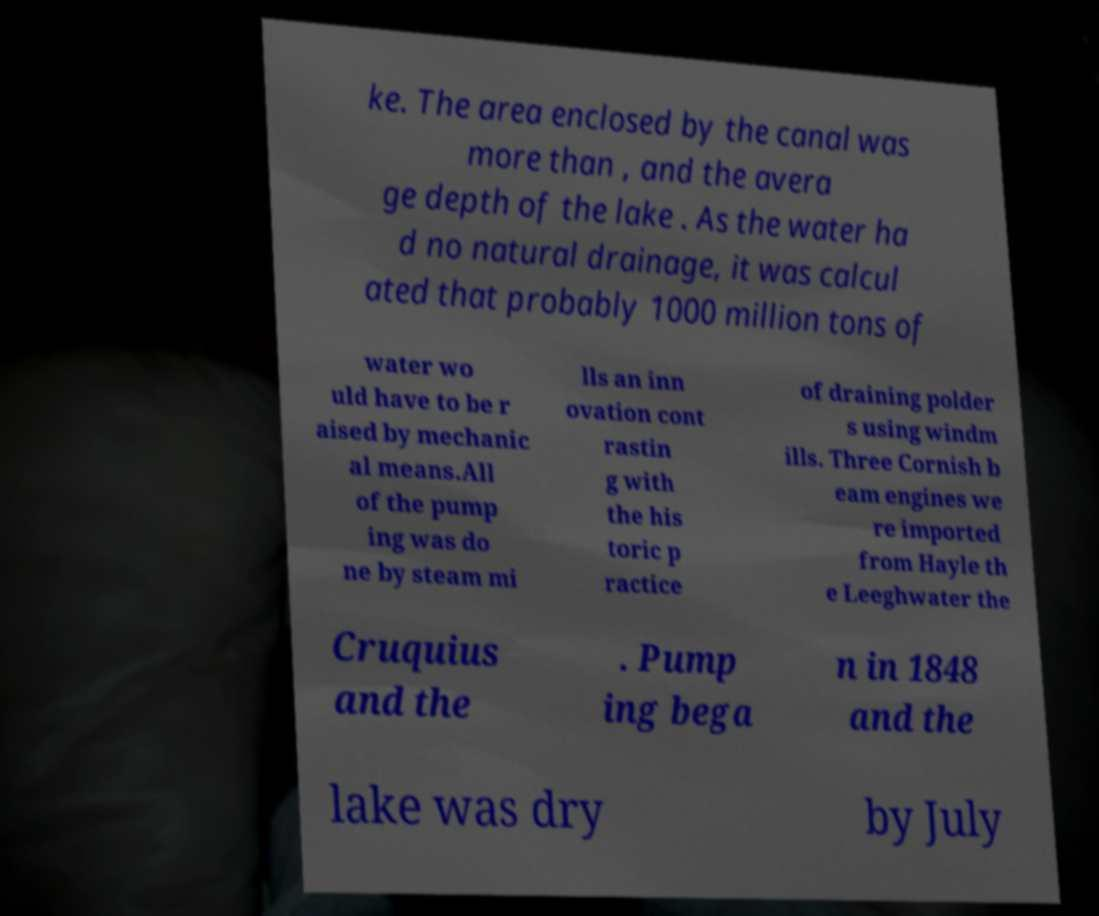Please identify and transcribe the text found in this image. ke. The area enclosed by the canal was more than , and the avera ge depth of the lake . As the water ha d no natural drainage, it was calcul ated that probably 1000 million tons of water wo uld have to be r aised by mechanic al means.All of the pump ing was do ne by steam mi lls an inn ovation cont rastin g with the his toric p ractice of draining polder s using windm ills. Three Cornish b eam engines we re imported from Hayle th e Leeghwater the Cruquius and the . Pump ing bega n in 1848 and the lake was dry by July 